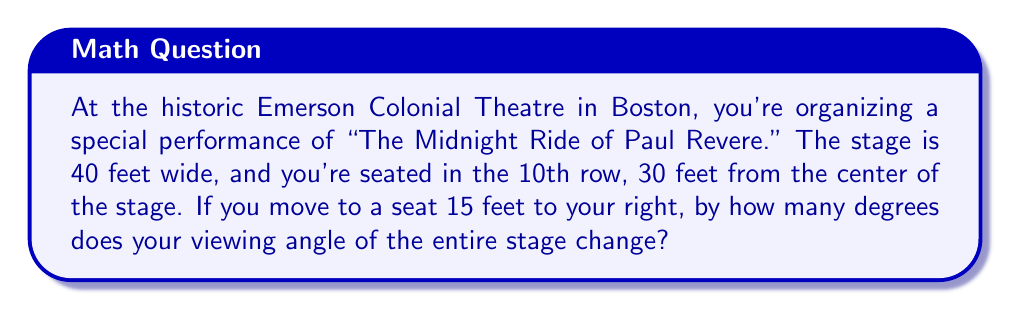Provide a solution to this math problem. Let's approach this step-by-step:

1) First, we need to visualize the problem. We can consider this as two right triangles sharing the same base (the distance to the stage).

[asy]
import geometry;

pair A = (0,0), B = (20,30), C = (-20,30), D = (15,0);
draw(A--B--C--A);
draw(D--B--C--D);
draw(A--D,dashed);

label("Stage", (0,31), N);
label("Initial position", A, S);
label("New position", D, S);
label("30 ft", (10,15), E);
label("15 ft", (7.5,0), S);
label("20 ft", (10,30), NW);
label("20 ft", (-10,30), NE);

dot(A); dot(B); dot(C); dot(D);
[/asy]

2) In both cases, we're dealing with right triangles. We need to find the angle at the viewer's position in each case and then find the difference.

3) For the initial position:
   The half-width of the stage is 20 feet (40/2).
   We can use the arctangent function to find the angle:
   $$\theta_1 = 2 \cdot \arctan(\frac{20}{30})$$

4) For the new position:
   We need to consider two right triangles: one for the left edge of the stage and one for the right edge.
   Left edge: $$\theta_L = \arctan(\frac{35}{30})$$
   Right edge: $$\theta_R = \arctan(\frac{5}{30})$$
   The total angle is: $$\theta_2 = \theta_L - \theta_R$$

5) The change in angle is the absolute difference between these angles:
   $$\Delta\theta = |\theta_1 - \theta_2|$$

6) Let's calculate:
   $$\theta_1 = 2 \cdot \arctan(\frac{20}{30}) \approx 67.38°$$
   $$\theta_L = \arctan(\frac{35}{30}) \approx 49.40°$$
   $$\theta_R = \arctan(\frac{5}{30}) \approx 9.46°$$
   $$\theta_2 = 49.40° - 9.46° = 39.94°$$
   $$\Delta\theta = |67.38° - 39.94°| = 27.44°$$
Answer: The viewing angle changes by approximately 27.44°. 